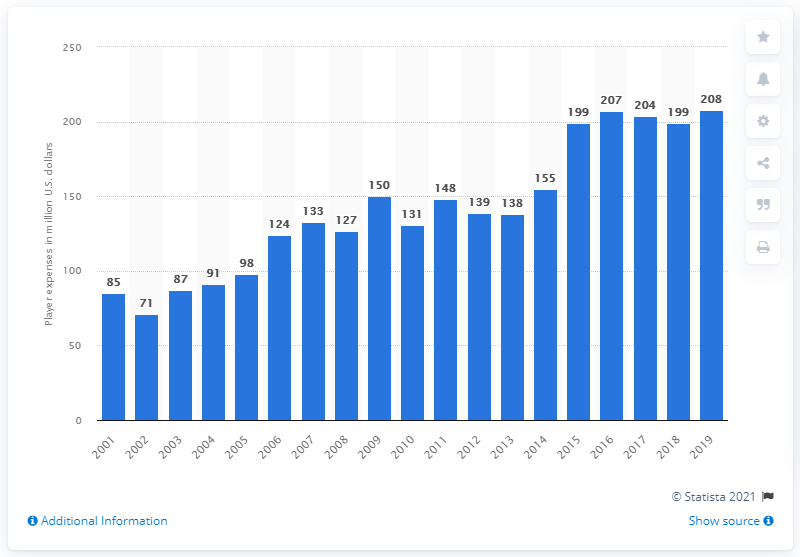Specify some key components in this picture. The expenses of the Los Angeles Chargers players in the 2019 season were 208 million dollars. 